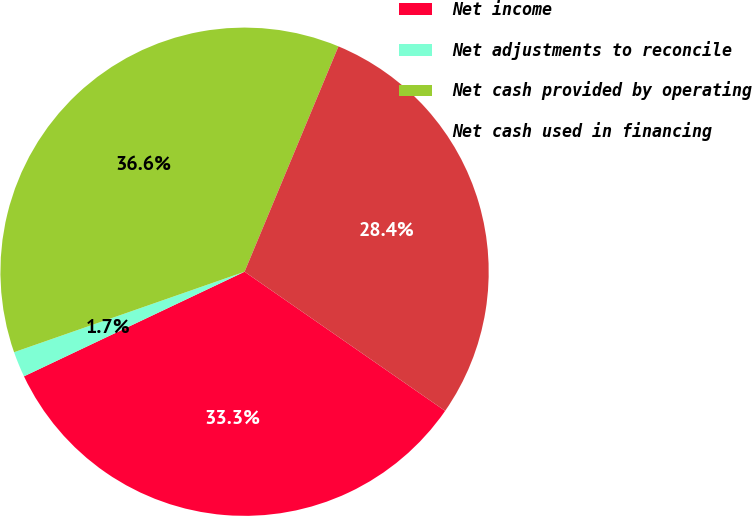Convert chart. <chart><loc_0><loc_0><loc_500><loc_500><pie_chart><fcel>Net income<fcel>Net adjustments to reconcile<fcel>Net cash provided by operating<fcel>Net cash used in financing<nl><fcel>33.3%<fcel>1.7%<fcel>36.63%<fcel>28.37%<nl></chart> 